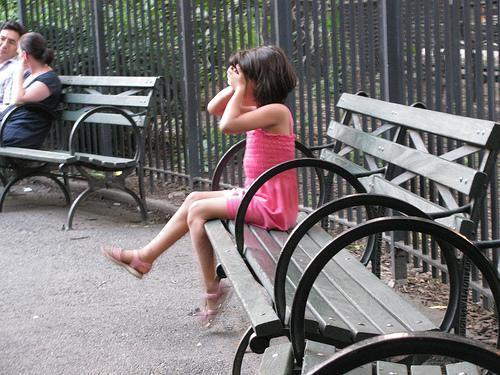How many people are shown?
Give a very brief answer. 3. How many people are sitting on the bench to the far left?
Give a very brief answer. 2. How many horizontal slats make up the back of the benches?
Give a very brief answer. 3. 